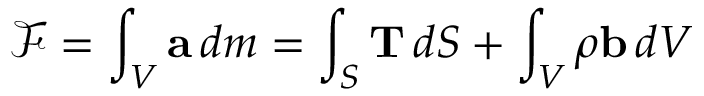<formula> <loc_0><loc_0><loc_500><loc_500>{ \mathcal { F } } = \int _ { V } a \, d m = \int _ { S } T \, d S + \int _ { V } \rho b \, d V</formula> 